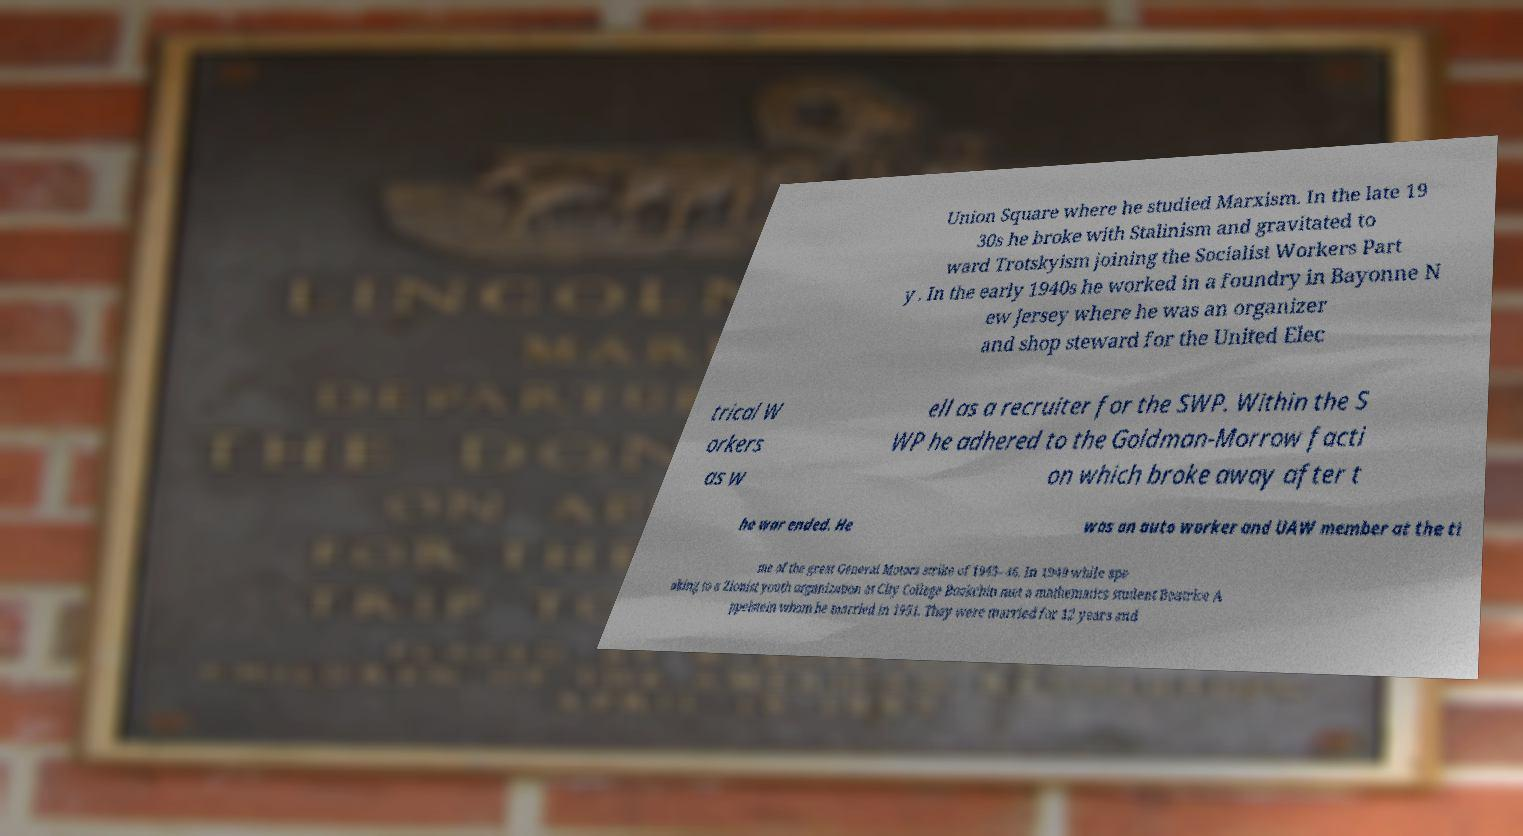Could you extract and type out the text from this image? Union Square where he studied Marxism. In the late 19 30s he broke with Stalinism and gravitated to ward Trotskyism joining the Socialist Workers Part y . In the early 1940s he worked in a foundry in Bayonne N ew Jersey where he was an organizer and shop steward for the United Elec trical W orkers as w ell as a recruiter for the SWP. Within the S WP he adhered to the Goldman-Morrow facti on which broke away after t he war ended. He was an auto worker and UAW member at the ti me of the great General Motors strike of 1945–46. In 1949 while spe aking to a Zionist youth organization at City College Bookchin met a mathematics student Beatrice A ppelstein whom he married in 1951. They were married for 12 years and 